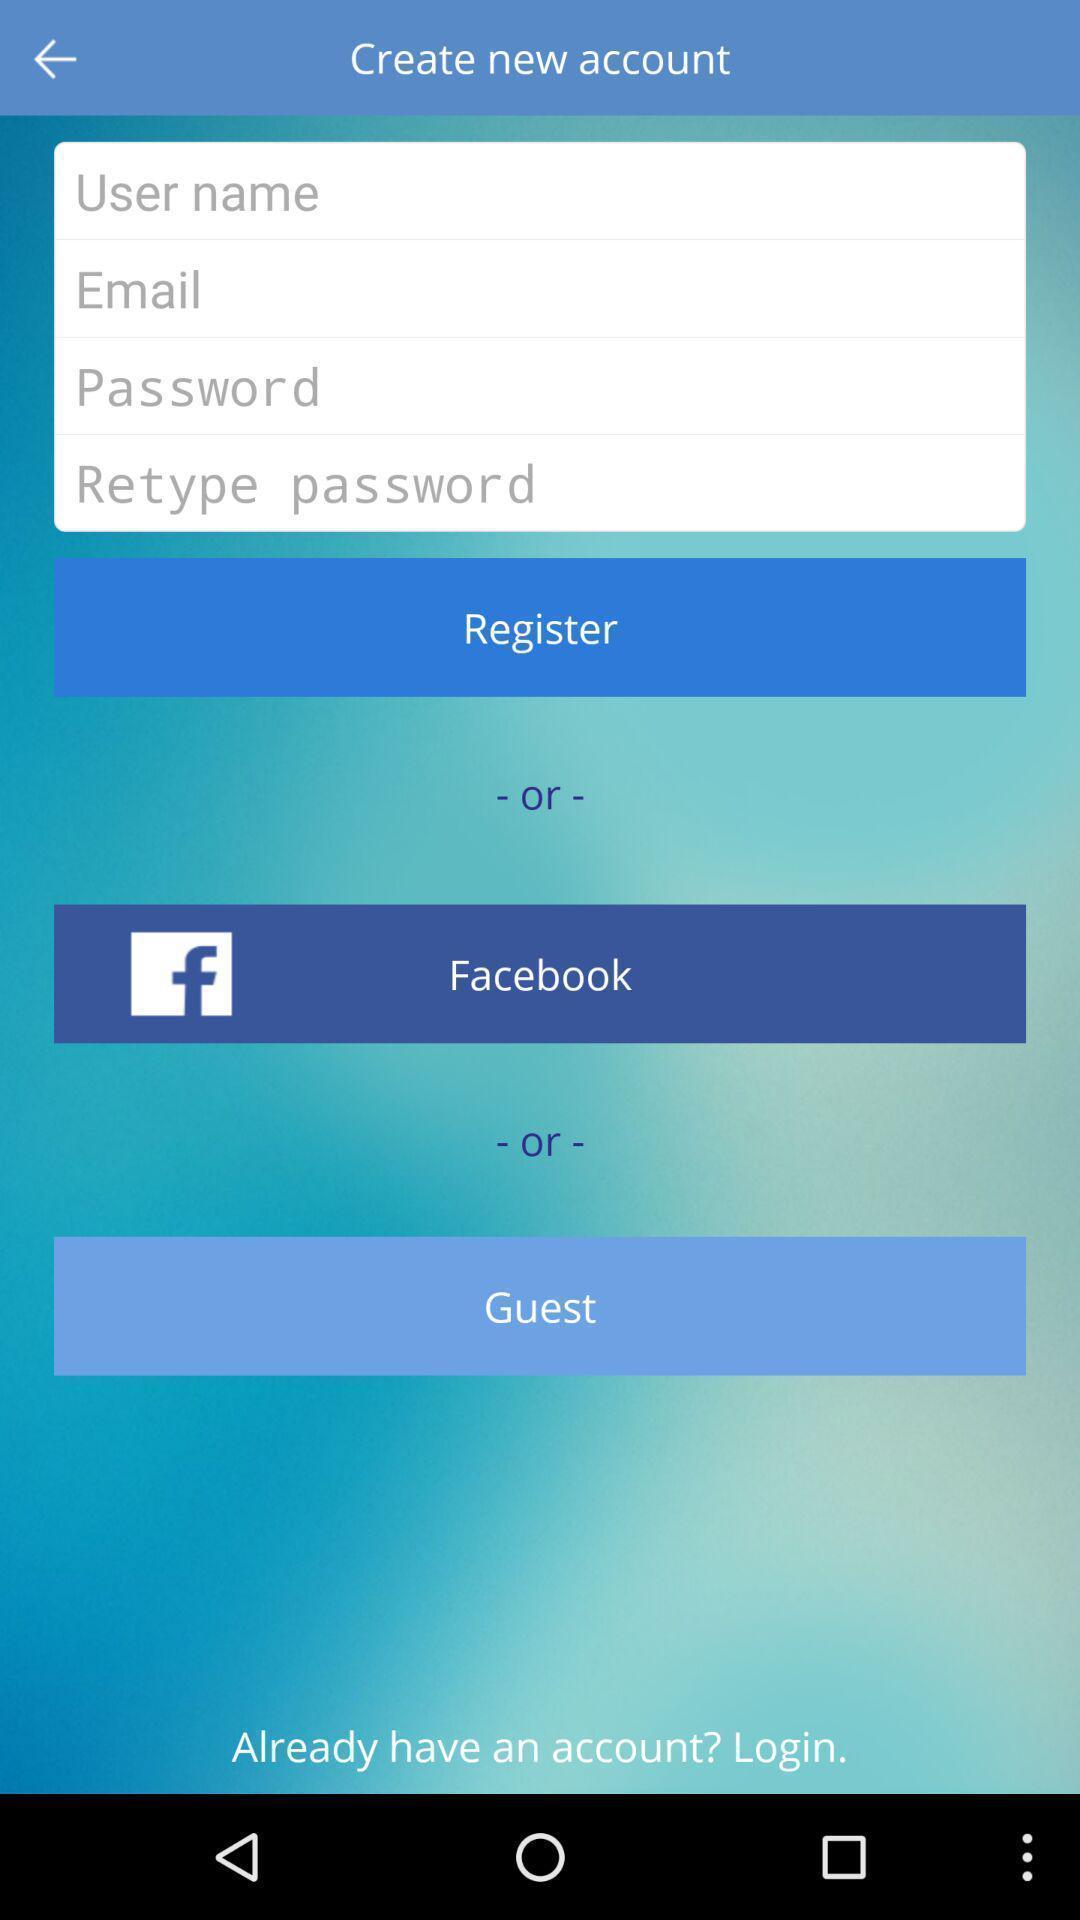Provide a description of this screenshot. Welcome to the sign in page. 